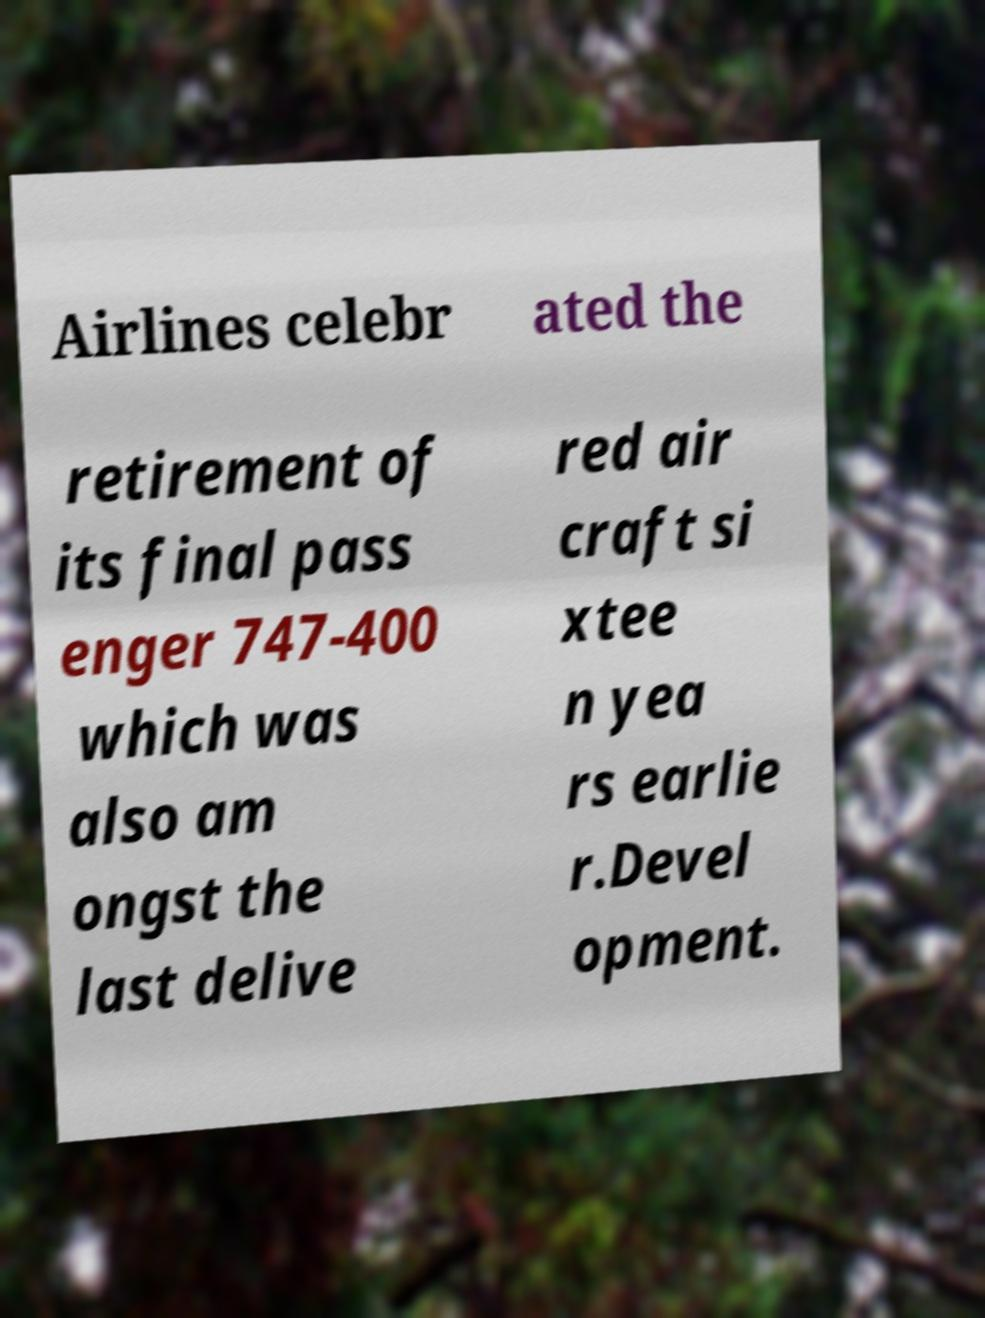For documentation purposes, I need the text within this image transcribed. Could you provide that? Airlines celebr ated the retirement of its final pass enger 747-400 which was also am ongst the last delive red air craft si xtee n yea rs earlie r.Devel opment. 